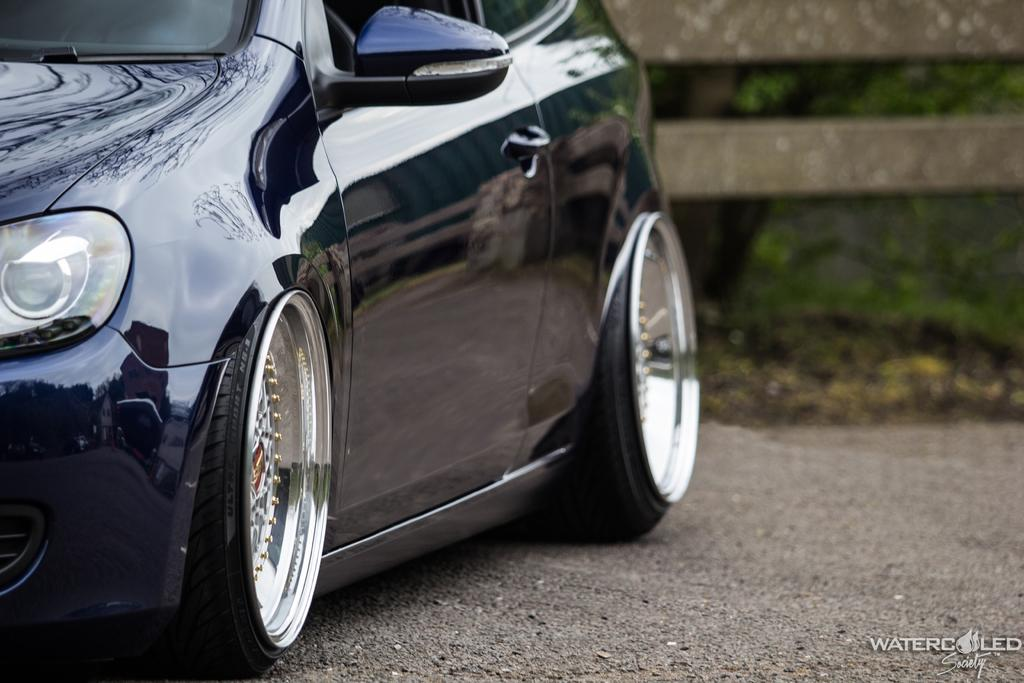What is the main subject of the image? There is a car in the image. Can you describe any additional features of the image? There is a watermark at the right bottom of the image, and trees are visible in the background. How many trips can the car take to the harbor in the image? There is no harbor present in the image, so it is not possible to determine how many trips the car can take to the harbor. 